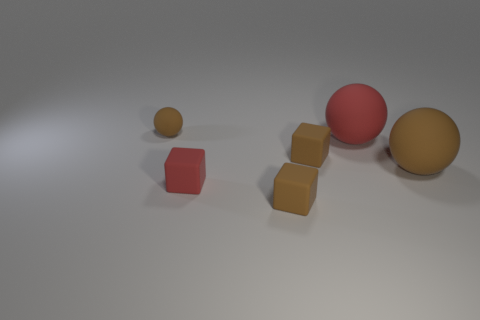Subtract all brown blocks. How many were subtracted if there are1brown blocks left? 1 Subtract all small rubber balls. How many balls are left? 2 Subtract all red cubes. How many cubes are left? 2 Subtract 1 balls. How many balls are left? 2 Subtract all balls. Subtract all brown cubes. How many objects are left? 1 Add 2 small red things. How many small red things are left? 3 Add 5 small brown rubber things. How many small brown rubber things exist? 8 Add 2 brown balls. How many objects exist? 8 Subtract 0 blue spheres. How many objects are left? 6 Subtract all purple balls. Subtract all purple cylinders. How many balls are left? 3 